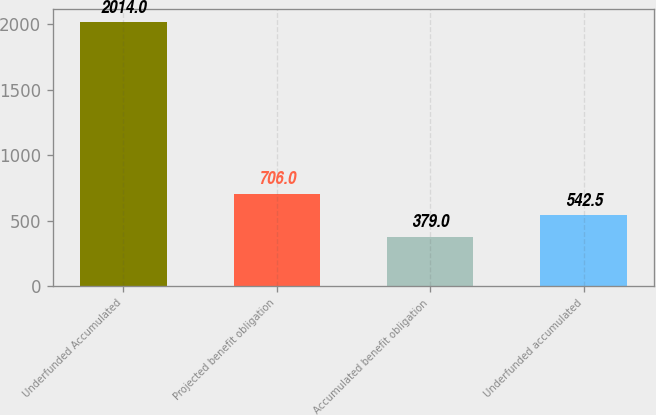<chart> <loc_0><loc_0><loc_500><loc_500><bar_chart><fcel>Underfunded Accumulated<fcel>Projected benefit obligation<fcel>Accumulated benefit obligation<fcel>Underfunded accumulated<nl><fcel>2014<fcel>706<fcel>379<fcel>542.5<nl></chart> 